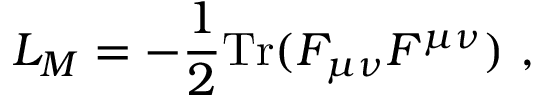Convert formula to latex. <formula><loc_0><loc_0><loc_500><loc_500>L _ { M } = - \frac { 1 } { 2 } T r ( F _ { \mu \nu } F ^ { \mu \nu } ) \ ,</formula> 